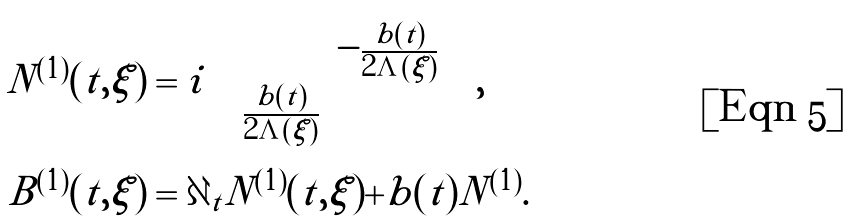Convert formula to latex. <formula><loc_0><loc_0><loc_500><loc_500>N ^ { ( 1 ) } ( t , \xi ) & = i \begin{pmatrix} & - \frac { b ( t ) } { 2 \Lambda ( \xi ) } \\ \frac { b ( t ) } { 2 \Lambda ( \xi ) } \end{pmatrix} , \\ B ^ { ( 1 ) } ( t , \xi ) & = \partial _ { t } N ^ { ( 1 ) } ( t , \xi ) + b ( t ) N ^ { ( 1 ) } .</formula> 